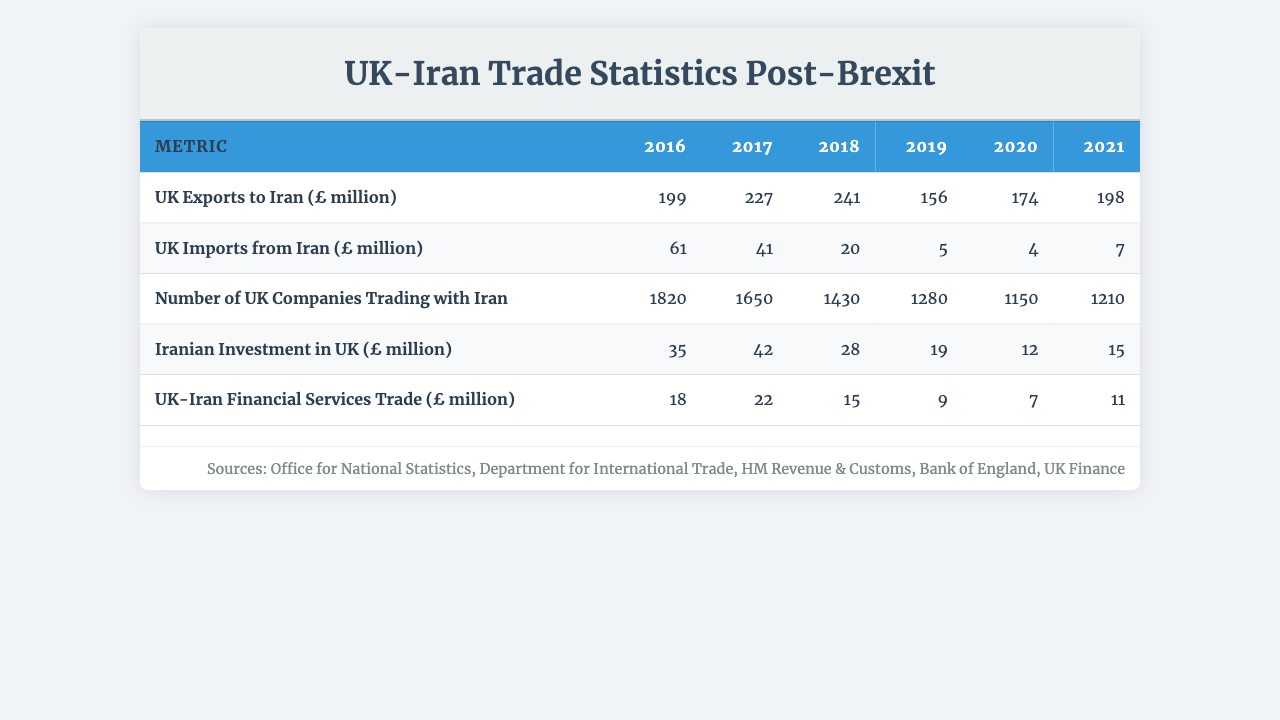What were the UK exports to Iran in 2020? According to the table, the value for UK exports to Iran in 2020 is found in the corresponding row, which is 174 million pounds.
Answer: 174 million pounds What is the total value of UK imports from Iran from 2016 to 2021? To find the total, we sum the values from each year: 61 + 41 + 20 + 5 + 4 + 7 = 138 million pounds.
Answer: 138 million pounds How many UK companies were trading with Iran in 2018? The table indicates that in 2018, the number of UK companies trading with Iran is 1430.
Answer: 1430 Was there an increase in Iranian investment in the UK from 2016 to 2017? Comparing the values, Iranian investment in the UK was 35 million pounds in 2016 and increased to 42 million pounds in 2017, indicating a yes.
Answer: Yes What is the average amount of UK exports to Iran from 2016 to 2021? We can calculate the average by summing the exports: 199 + 227 + 241 + 156 + 174 + 198 = 1195 million pounds, then dividing by 6 gives us 1195 / 6 = 199.17 million pounds.
Answer: 199.17 million pounds Has the number of UK companies trading with Iran shown a decline from 2016 to 2020? The values are 1820 (2016), 1650 (2017), 1430 (2018), 1280 (2019), 1150 (2020), which consistently show a decrease, confirming the decline.
Answer: Yes What was the highest value of UK exports to Iran in the given years? Review the export values (199, 227, 241, 156, 174, 198 million pounds) and identify the highest value, which is 241 million pounds in 2018.
Answer: 241 million pounds What is the percentage increase in UK imports from Iran from 2020 to 2021? The imports in 2020 were 4 million pounds and in 2021, 7 million pounds. The increase is 7 - 4 = 3 million pounds. To find the percentage increase, (3/4) * 100 = 75%.
Answer: 75% Which year had the lowest UK-Iran financial services trade, and what was the amount? By looking at the financial services trade figures (18, 22, 15, 9, 7, 11 million pounds), we find the lowest amount was 7 million pounds in 2020.
Answer: 2020, 7 million pounds What can be inferred about the trend of UK exports to Iran from 2016 to 2019? The values are 199, 227, 241, 156 million pounds. From 2016 to 2018, the exports increased, but they then fell in 2019, indicating a fluctuation in exports.
Answer: Fluctuation in exports 